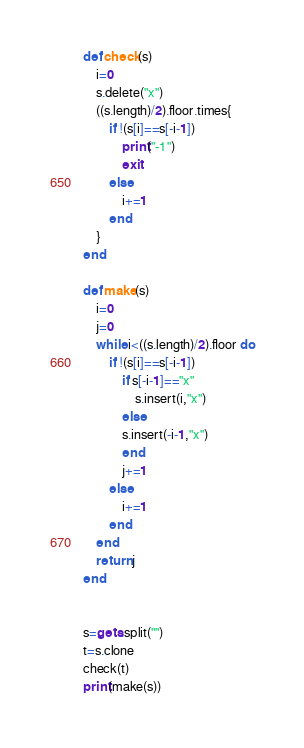<code> <loc_0><loc_0><loc_500><loc_500><_Ruby_>def check(s)
    i=0
    s.delete("x")
    ((s.length)/2).floor.times{
        if !(s[i]==s[-i-1])
            print("-1")
            exit
        else
            i+=1
        end
    }
end

def make(s)
    i=0
    j=0
    while i<((s.length)/2).floor do
        if !(s[i]==s[-i-1])
            if s[-i-1]=="x"
                s.insert(i,"x") 
            else
            s.insert(-i-1,"x")
            end
            j+=1
        else
            i+=1
        end
    end
    return j
end


s=gets.split("")
t=s.clone
check(t)
print(make(s))</code> 